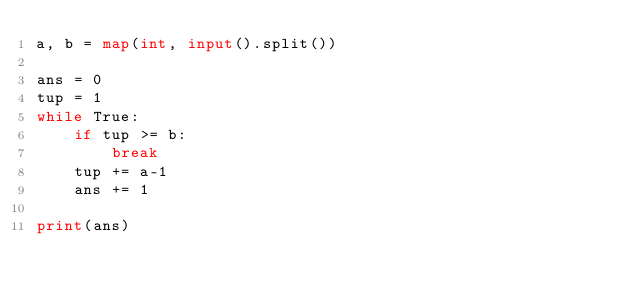<code> <loc_0><loc_0><loc_500><loc_500><_Python_>a, b = map(int, input().split())

ans = 0
tup = 1
while True:
    if tup >= b:
        break
    tup += a-1
    ans += 1

print(ans)
</code> 